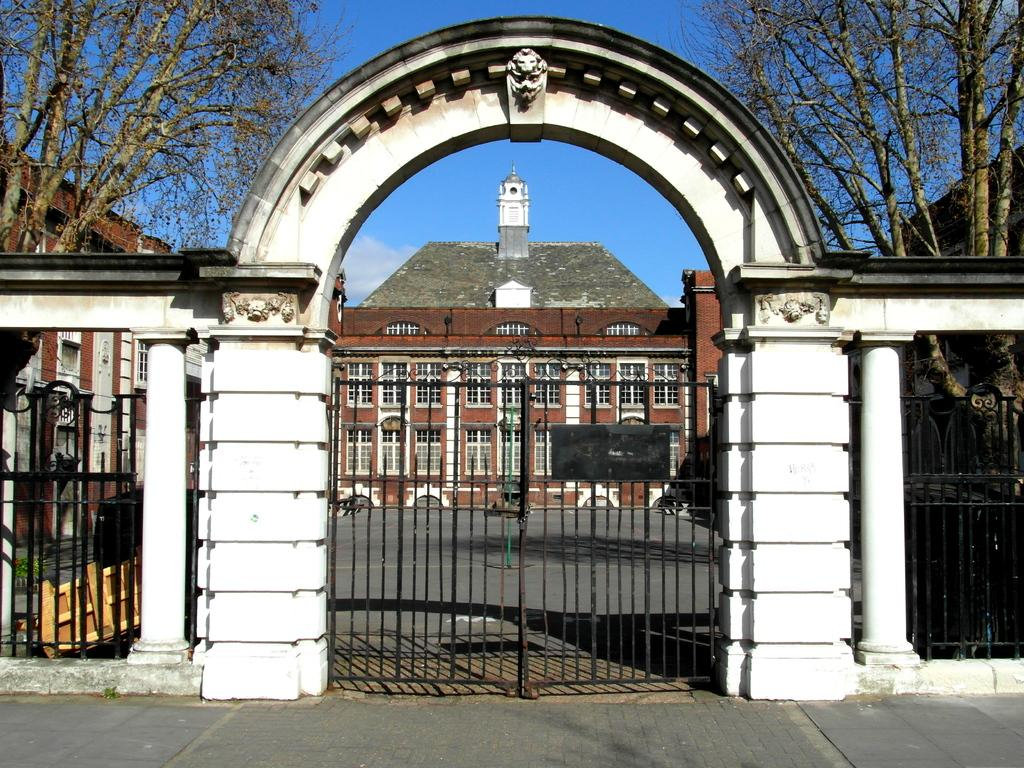What architectural features can be seen in the image? There are pillars, gates, grills, and an arch visible in the image. What is located at the bottom of the image? There is a platform at the bottom of the image. What can be seen in the background of the image? There are buildings, trees, and the sky visible in the background of the image. Where is the box placed in the image? There is no box present in the image. What level is the shelf located on in the image? There is no shelf present in the image. 